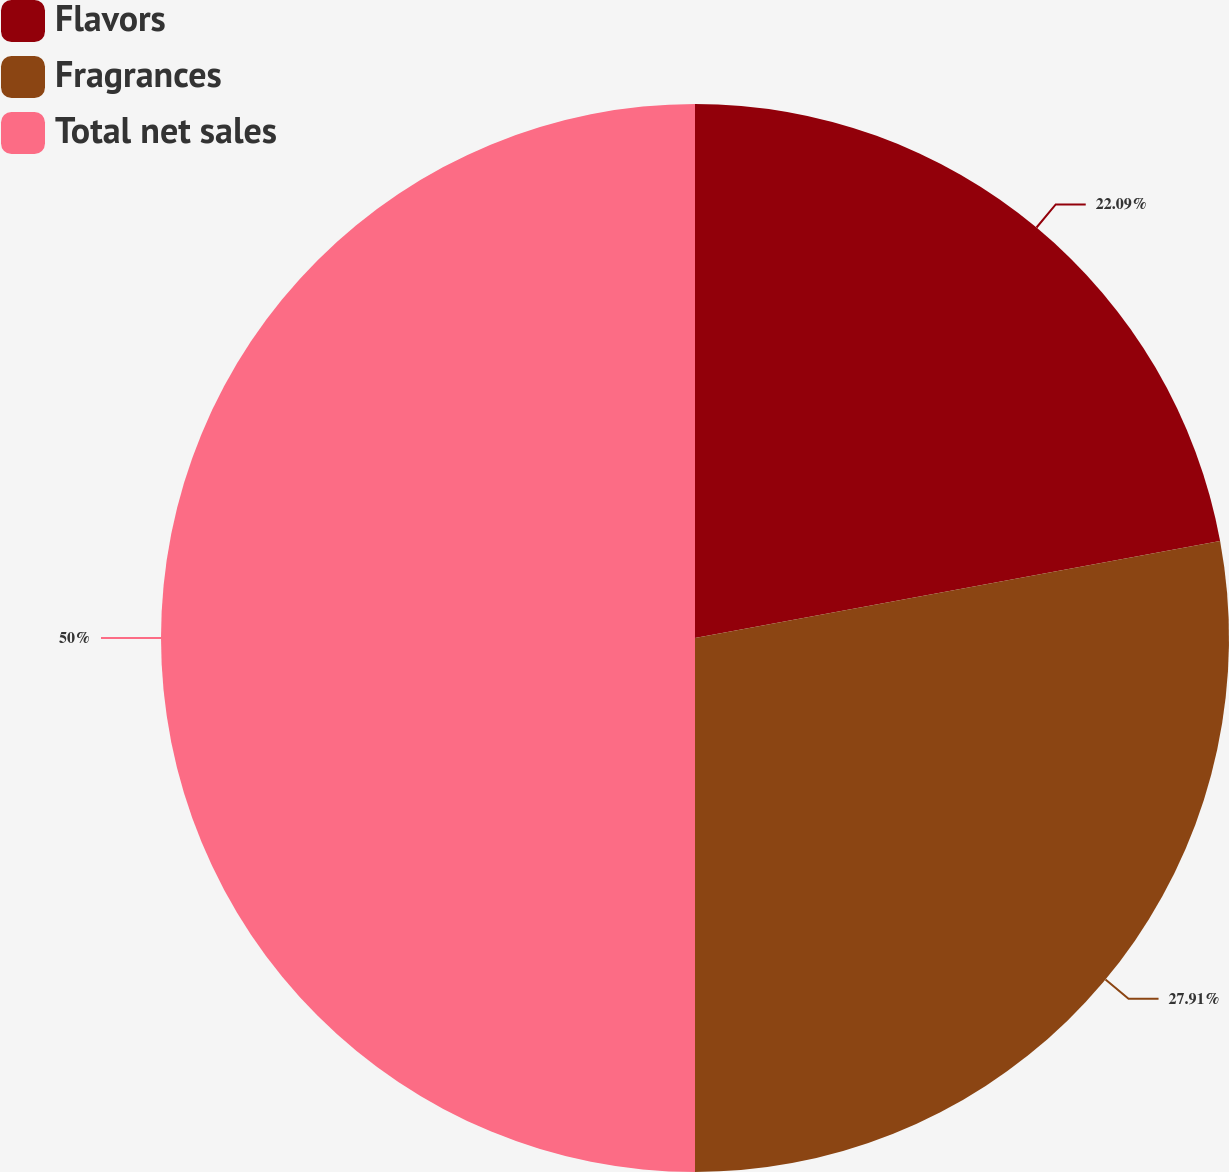Convert chart to OTSL. <chart><loc_0><loc_0><loc_500><loc_500><pie_chart><fcel>Flavors<fcel>Fragrances<fcel>Total net sales<nl><fcel>22.09%<fcel>27.91%<fcel>50.0%<nl></chart> 